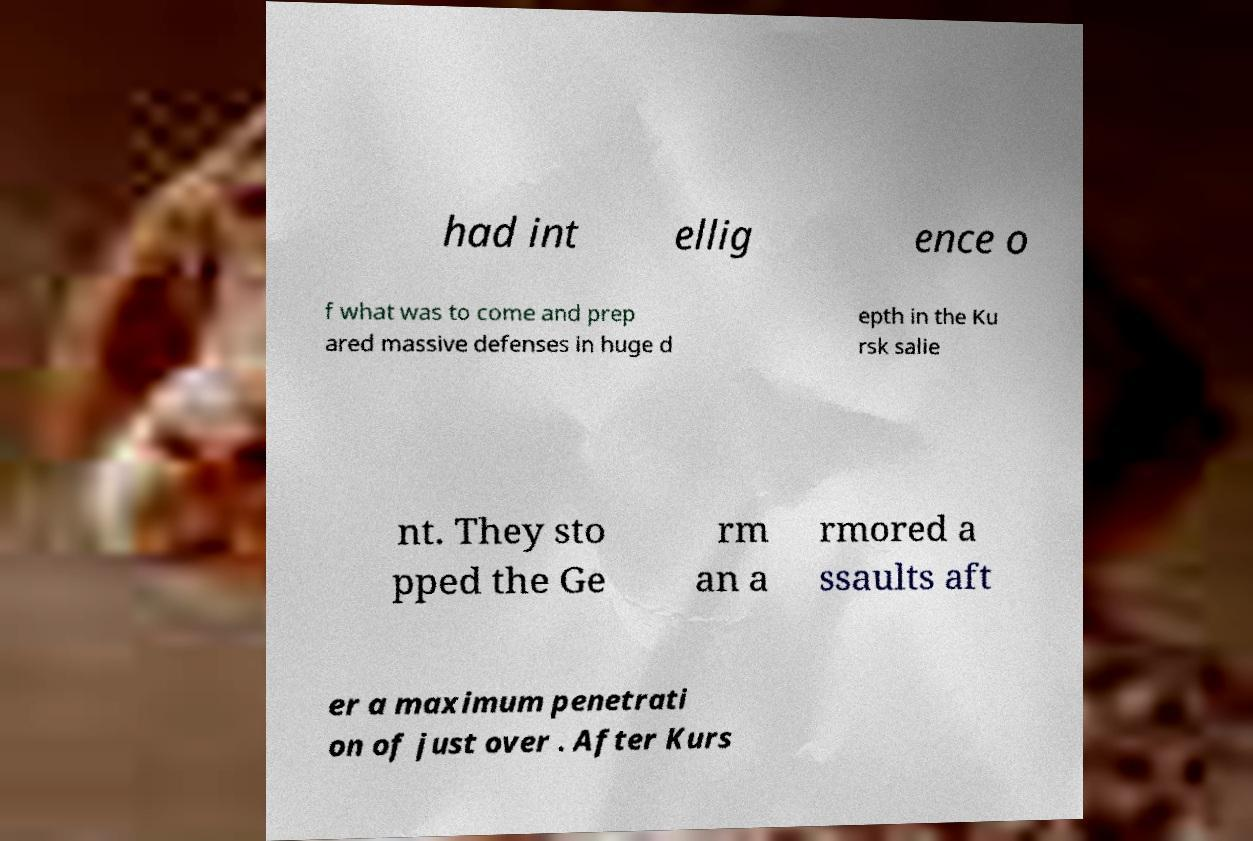Could you extract and type out the text from this image? had int ellig ence o f what was to come and prep ared massive defenses in huge d epth in the Ku rsk salie nt. They sto pped the Ge rm an a rmored a ssaults aft er a maximum penetrati on of just over . After Kurs 